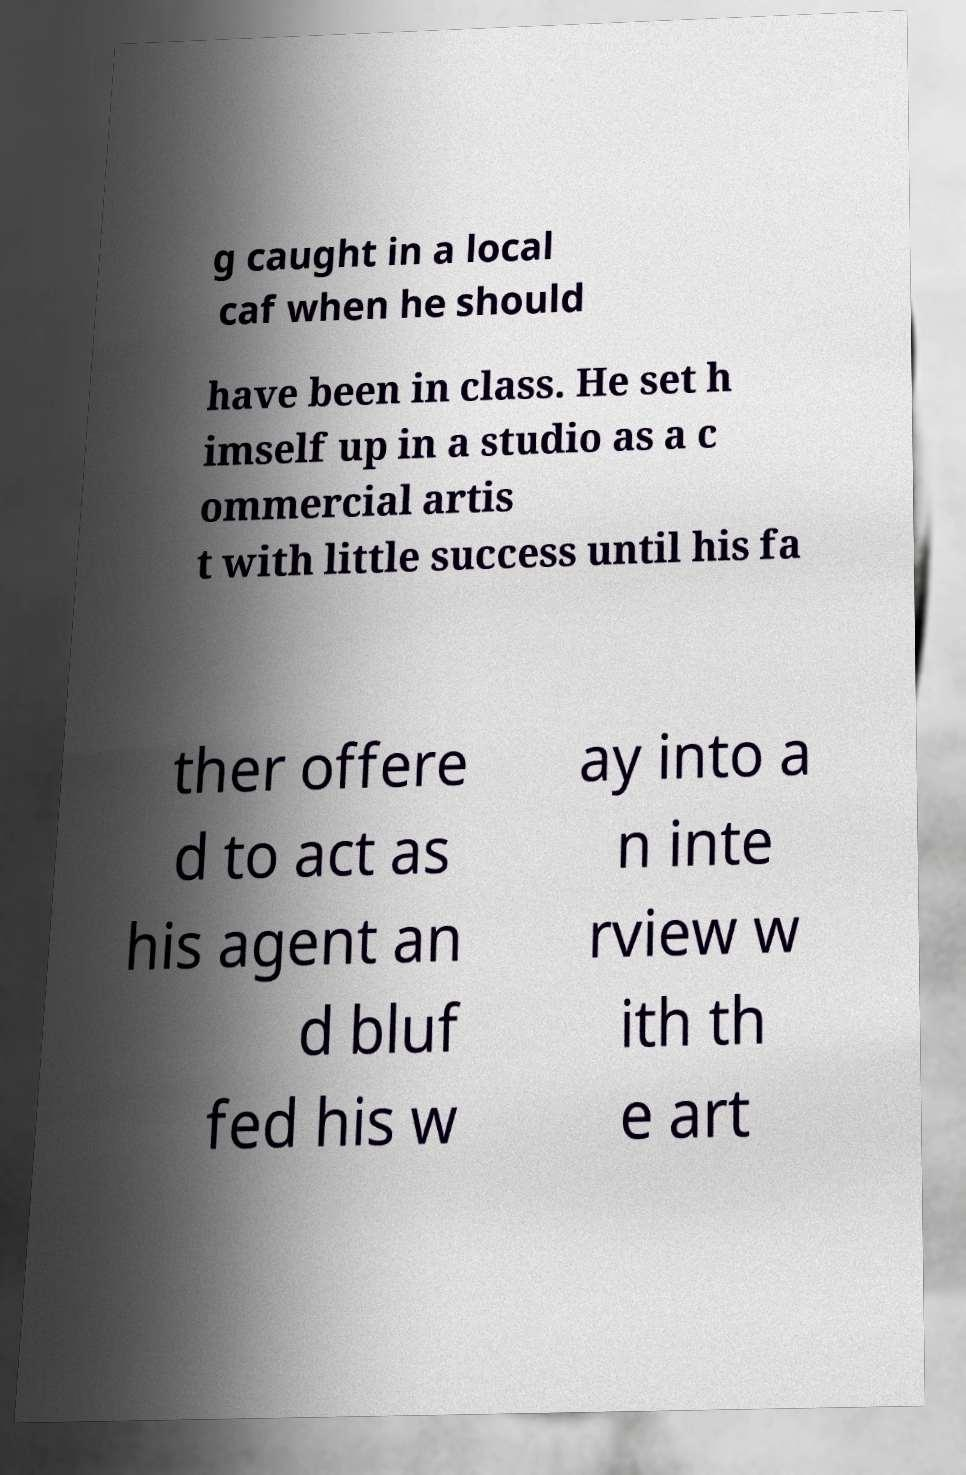I need the written content from this picture converted into text. Can you do that? g caught in a local caf when he should have been in class. He set h imself up in a studio as a c ommercial artis t with little success until his fa ther offere d to act as his agent an d bluf fed his w ay into a n inte rview w ith th e art 